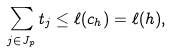<formula> <loc_0><loc_0><loc_500><loc_500>\sum _ { j \in J _ { p } } t _ { j } \leq \ell ( c _ { h } ) = \ell ( h ) ,</formula> 